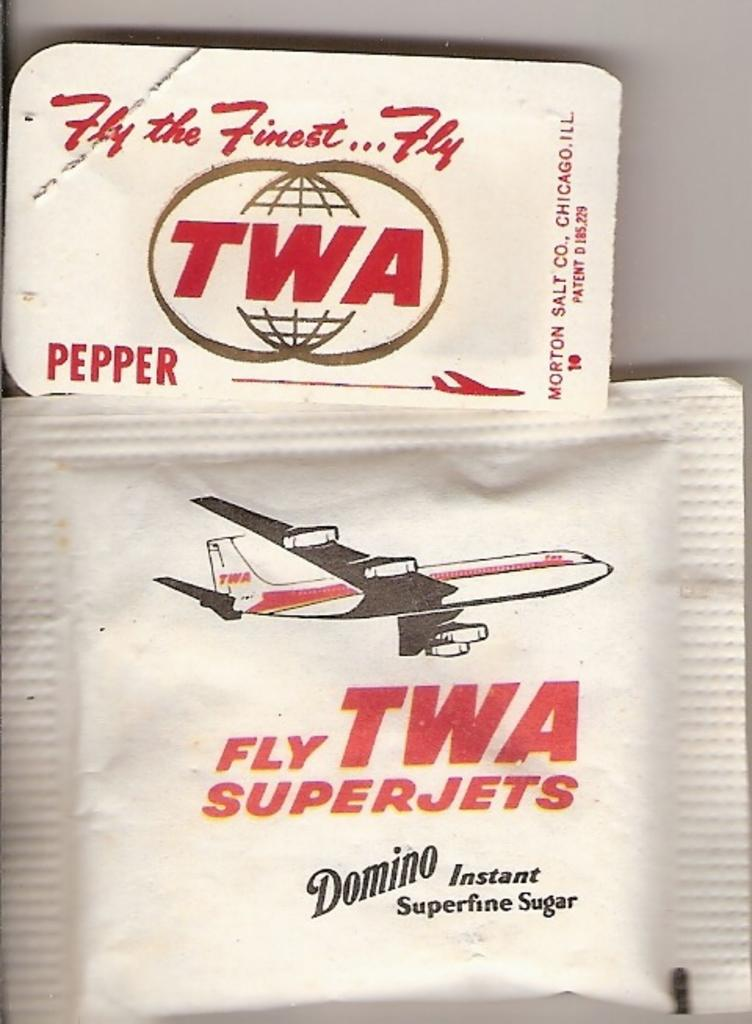Provide a one-sentence caption for the provided image. Packets of sugar and pepper with an old TWA logo on them. 